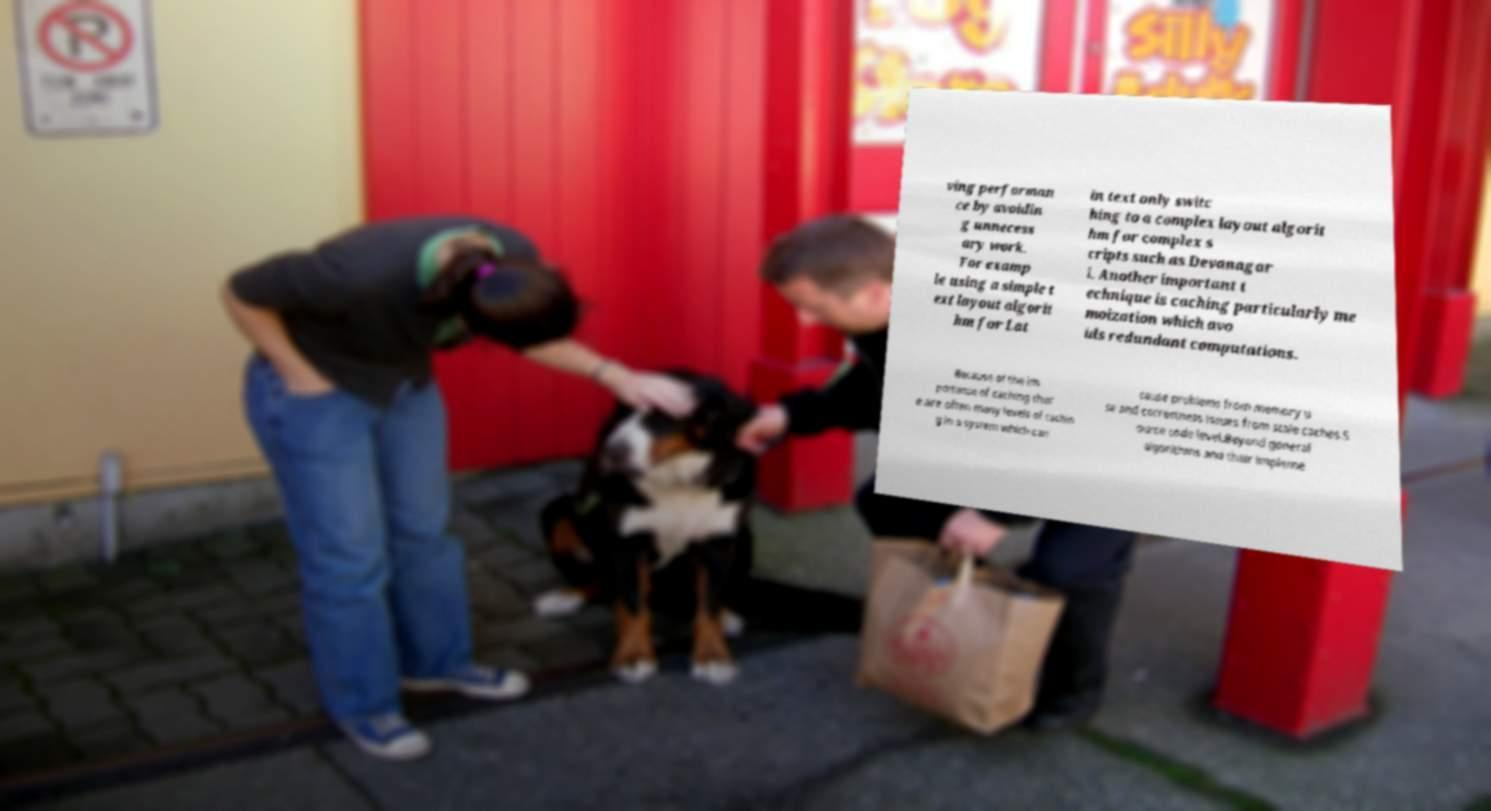I need the written content from this picture converted into text. Can you do that? ving performan ce by avoidin g unnecess ary work. For examp le using a simple t ext layout algorit hm for Lat in text only switc hing to a complex layout algorit hm for complex s cripts such as Devanagar i. Another important t echnique is caching particularly me moization which avo ids redundant computations. Because of the im portance of caching ther e are often many levels of cachin g in a system which can cause problems from memory u se and correctness issues from stale caches.S ource code level.Beyond general algorithms and their impleme 